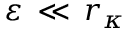<formula> <loc_0><loc_0><loc_500><loc_500>\varepsilon \, \ll \, r _ { \kappa }</formula> 